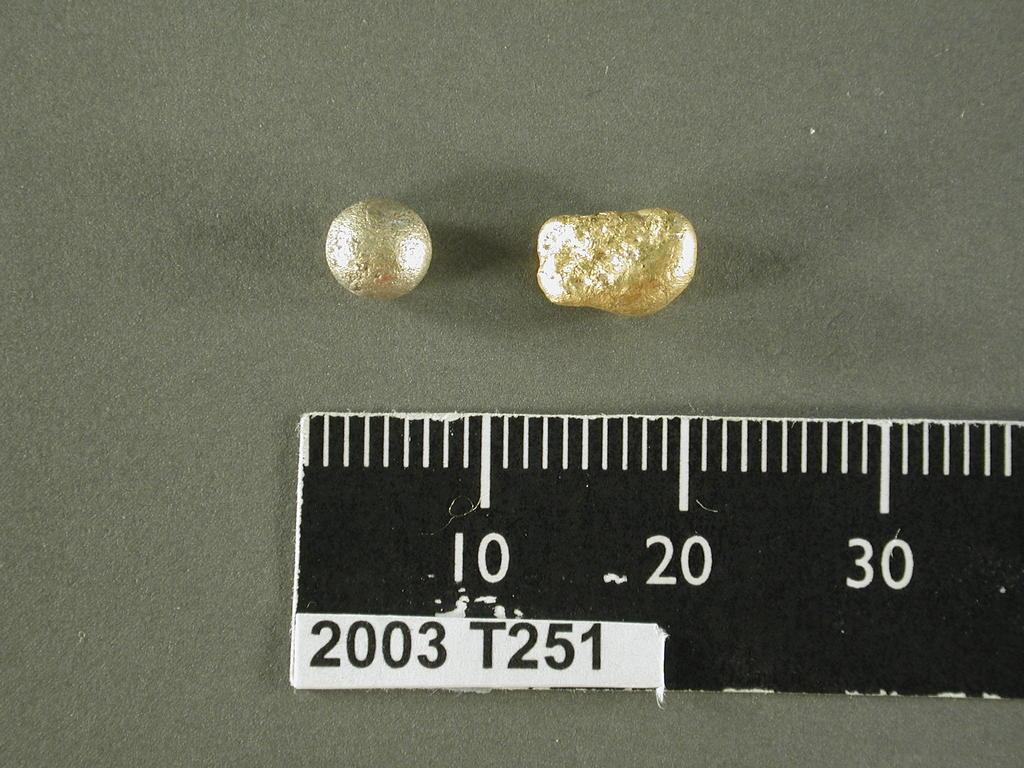<image>
Create a compact narrative representing the image presented. ruler with 2003 t251 on it showing size of a gold sphere and a gold nugget 